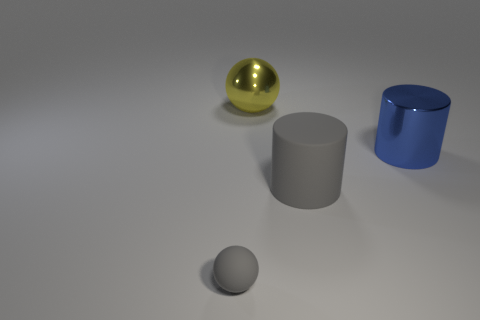Add 3 small purple blocks. How many objects exist? 7 Subtract all large gray things. Subtract all large metallic cylinders. How many objects are left? 2 Add 2 large metal cylinders. How many large metal cylinders are left? 3 Add 3 large yellow metal spheres. How many large yellow metal spheres exist? 4 Subtract 0 blue balls. How many objects are left? 4 